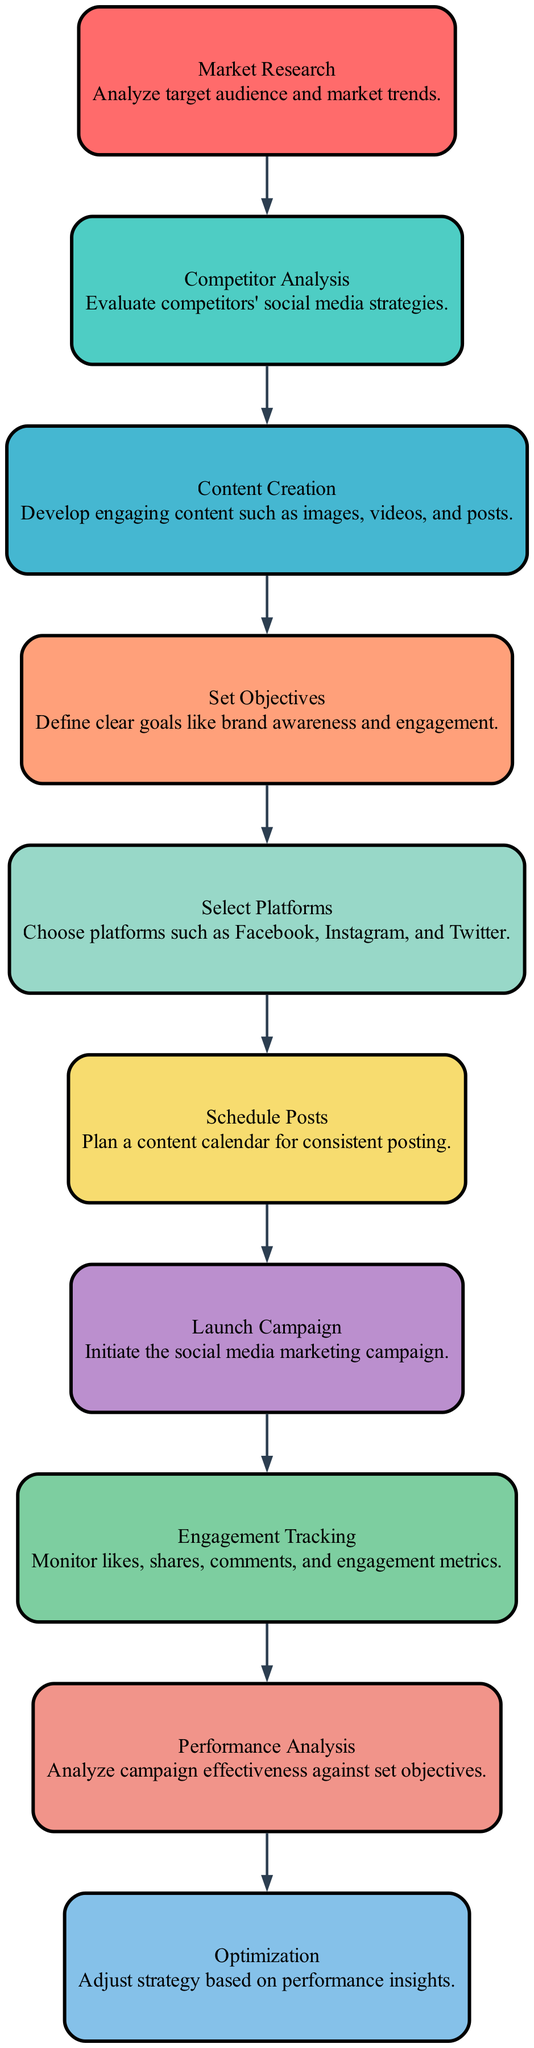What is the first step in the campaign flowchart? The first step in the campaign flowchart is identified as "Market Research," as it is the first node in the directed graph.
Answer: Market Research How many total elements are in the diagram? The diagram includes a total of 10 elements, which are the different steps of the social media marketing campaign.
Answer: 10 What is the last step in the campaign flowchart? The last step in the campaign flowchart is known as "Optimization," as indicated by the final node in the directed graph connected from the previous node.
Answer: Optimization Which step follows "Content Creation"? The node that directly follows "Content Creation" in the flowchart is "Set Objectives," as shown by the directed edge connecting these two nodes.
Answer: Set Objectives What are the two nodes before "Launch Campaign"? The two nodes preceding "Launch Campaign" are "Schedule Posts" and "Select Platforms," and both feed into the Launch Campaign step in the progression of the flowchart.
Answer: Schedule Posts, Select Platforms What metric is monitored during "Engagement Tracking"? "Engagement Tracking" involves monitoring metrics such as likes, shares, comments, and engagement metrics, as described in the node for this step in the flowchart.
Answer: Likes, shares, comments, and engagement metrics What is the relationship between "Performance Analysis" and "Engagement Tracking"? The relationship is sequential; "Engagement Tracking" occurs prior to "Performance Analysis," indicating that engagement metrics must be tracked first before performing analysis on them.
Answer: Engagement Tracking -> Performance Analysis What is the main goal of the "Set Objectives" step? The main goal of the "Set Objectives" step is to define clear goals, such as brand awareness and engagement, as stated in the description of this node in the diagram.
Answer: Define clear goals like brand awareness and engagement 